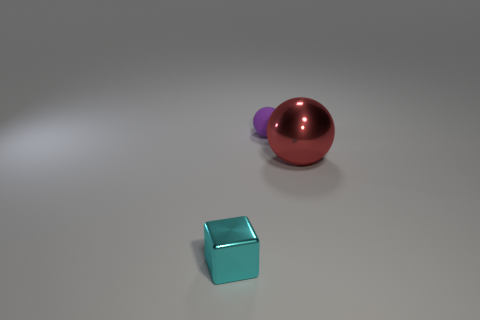What is the relationship between the objects in terms of color? The objects appear to be carefully chosen to contrast in color. The cyan cube in the foreground is a light blue, which has a cool and calm tone. The sphere behind it shows a gradation from pink to a deep red, providing a warm contrast. Meanwhile, the purple object, slightly out of focus, adds depth to the color palette used in the scene. 